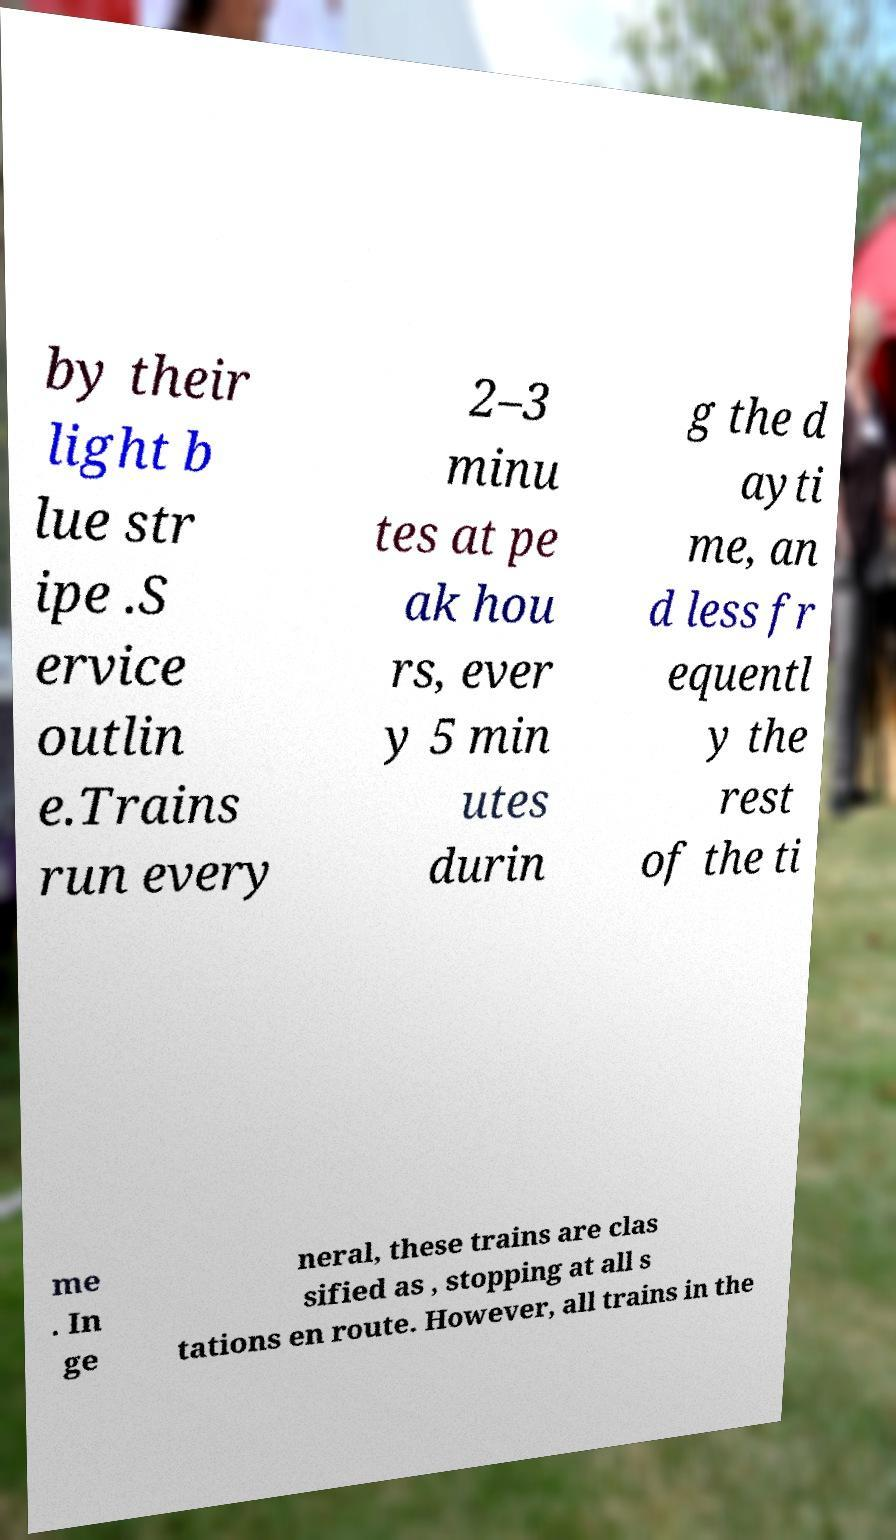Could you assist in decoding the text presented in this image and type it out clearly? by their light b lue str ipe .S ervice outlin e.Trains run every 2–3 minu tes at pe ak hou rs, ever y 5 min utes durin g the d ayti me, an d less fr equentl y the rest of the ti me . In ge neral, these trains are clas sified as , stopping at all s tations en route. However, all trains in the 